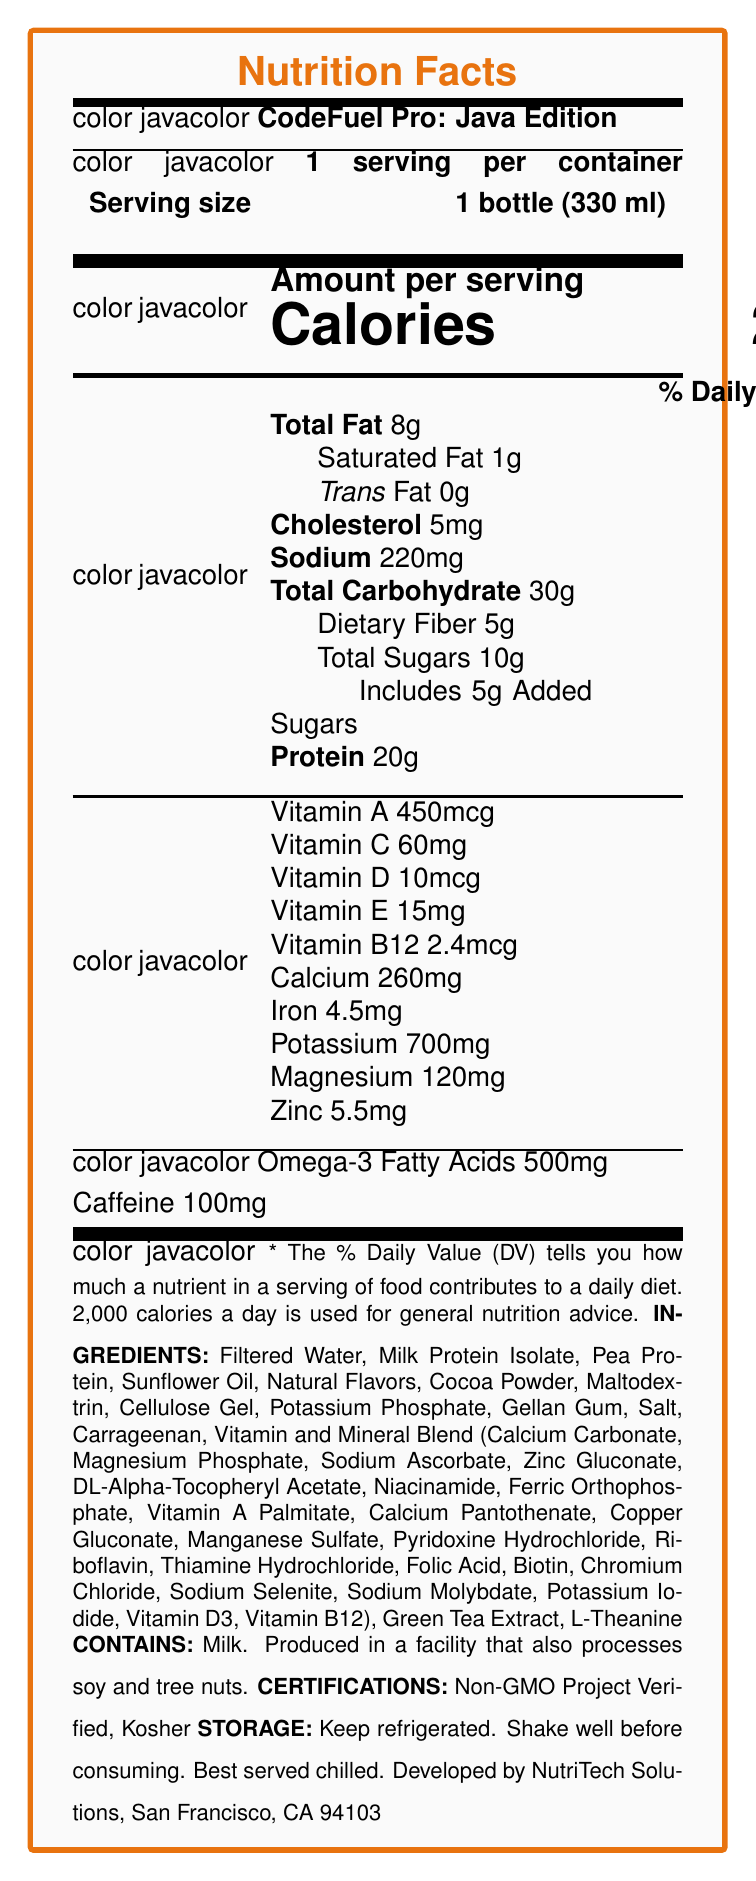how many calories are in one serving? The document states: “Calories: 250” under the amount per serving section.
Answer: 250 What is the serving size for CodeFuel Pro: Java Edition? The document specifies: "Serving size: 1 bottle (330 ml)".
Answer: 1 bottle (330 ml) How much protein is in one serving, and what percentage of the daily value does it represent? According to the document, one serving provides “Protein: 20g” and “% Daily Value: 40%”.
Answer: 20g, 40% Name three types of vitamins included in this product. The document mentions several vitamins, including Vitamin A, Vitamin C, and Vitamin D.
Answer: Vitamin A, Vitamin C, Vitamin D What are the storage instructions for this product? The document provides: "STORAGE: Keep refrigerated. Shake well before consuming. Best served chilled."
Answer: Keep refrigerated. Shake well before consuming. Best served chilled. How much caffeine does CodeFuel Pro: Java Edition contain? The document underlines: "Caffeine: 100mg".
Answer: 100 mg Does CodeFuel Pro: Java Edition contain any allergens? The document has a section that states: "CONTAINS: Milk. Produced in a facility that also processes soy and tree nuts."
Answer: Yes In which city was this product developed? The manufacturer info section notes: "Developed by NutriTech Solutions, San Francisco, CA 94103".
Answer: San Francisco, CA 94103 Which certification does this product hold? The document lists its certifications as: "Non-GMO Project Verified, Kosher".
Answer: Non-GMO Project Verified, Kosher What is the main idea of this document? This is an overview based on the various sections described in the document.
Answer: The document describes the Nutrition Facts of CodeFuel Pro: Java Edition, a vitamin-fortified meal replacement shake engineered for busy software engineers. It includes detailed information about the serving size, nutritional content, ingredients, allergens, certifications, storage instructions, and manufacturer details. True or False: This product is designed specifically for software engineers. The product name "CodeFuel Pro: Java Edition" and the special features targeting long coding sessions indicate that it is designed for software engineers.
Answer: True How much saturated fat does one serving of CodeFuel Pro: Java Edition contain? The document specifies: “Saturated Fat: 1g” under the total fat section.
Answer: 1g Which of the following describes CodeFuel Pro's protein content?  I. 100% of daily value  II. 20% of daily value  III. 40% of daily value The document indicates: "Protein: 20g, 40% daily value". Option III matches this.
Answer: III. 40% of daily value Which of the following vitamins has the highest daily value percentage in CodeFuel Pro: Java Edition?  A. Vitamin A  B. Vitamin C  C. Vitamin E  D. Vitamin B12 The document states that Vitamin E has a daily value of 100%, which is higher than the other listed vitamins.
Answer: C. Vitamin E What is the total amount of potassium in one serving? The document lists: “Potassium: 700mg” under its nutritional content.
Answer: 700mg How many servings are there per container? The document denotes: "1 serving per container".
Answer: 1 List four ingredients in CodeFuel Pro: Java Edition. The document lists the ingredients, including Filtered Water, Milk Protein Isolate, Pea Protein, and Sunflower Oil, among others.
Answer: Filtered Water, Milk Protein Isolate, Pea Protein, Sunflower Oil Is it possible to determine the amount of Vitamin K in CodeFuel Pro: Java Edition from this document? The document does not mention Vitamin K.
Answer: Not enough information What is the daily value percentage of dietary fiber in one serving? The document specifies: "Dietary Fiber: 5g, 18%" under the total carbohydrate section.
Answer: 18% What special features make this product useful for software engineers? The document lists special features like high protein, added caffeine and L-theanine, fortified vitamins and minerals, balanced macronutrients, and omega-3 fatty acids aimed at supporting busy software engineers.
Answer: High in protein for sustained energy, added caffeine and L-theanine for focus, fortified with vitamins/minerals, balanced macronutrients, omega-3 fatty acids for brain health 